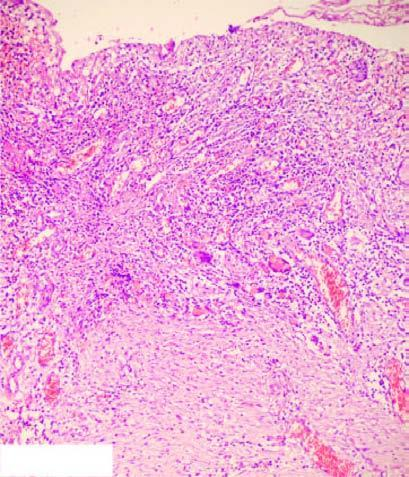what are histologic zones of the ulcer illustrated in?
Answer the question using a single word or phrase. Diagram 